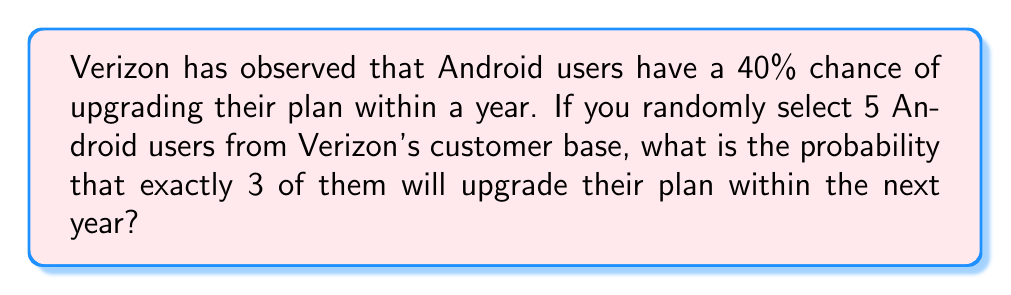Give your solution to this math problem. To solve this problem, we'll use the Binomial probability formula, as we're dealing with a fixed number of independent trials (selecting 5 Android users) with a constant probability of success (40% chance of upgrading).

The Binomial probability formula is:

$$P(X = k) = \binom{n}{k} p^k (1-p)^{n-k}$$

Where:
$n$ = number of trials (5 Android users)
$k$ = number of successes (3 upgrades)
$p$ = probability of success (40% = 0.4)

Step 1: Calculate the binomial coefficient $\binom{n}{k}$
$$\binom{5}{3} = \frac{5!}{3!(5-3)!} = \frac{5 \cdot 4}{2 \cdot 1} = 10$$

Step 2: Calculate $p^k$
$$(0.4)^3 = 0.064$$

Step 3: Calculate $(1-p)^{n-k}$
$$(1-0.4)^{5-3} = (0.6)^2 = 0.36$$

Step 4: Multiply the results from steps 1, 2, and 3
$$10 \cdot 0.064 \cdot 0.36 = 0.2304$$

Therefore, the probability of exactly 3 out of 5 randomly selected Android Verizon customers upgrading their plan within a year is 0.2304 or 23.04%.
Answer: 0.2304 